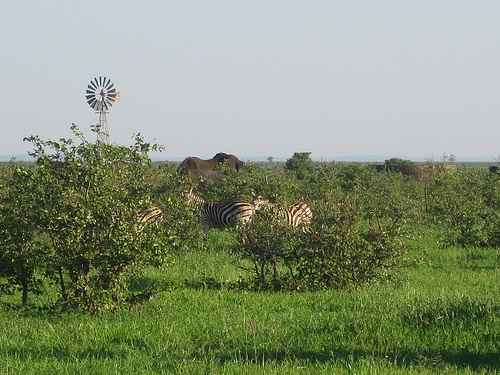Describe the objects in this image and their specific colors. I can see zebra in lightgray, black, gray, darkgreen, and tan tones, zebra in lightgray, olive, tan, and gray tones, elephant in lightgray, gray, and black tones, and zebra in lightgray, tan, olive, and black tones in this image. 